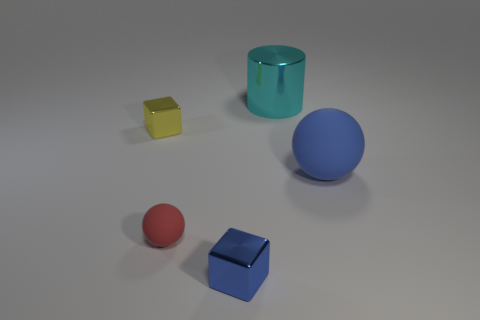What shape is the cyan metal thing? The cyan object appears to be a cylinder, which is a three-dimensional shape with two parallel circular bases connected by a curved surface at a fixed distance from each other. 